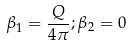<formula> <loc_0><loc_0><loc_500><loc_500>\beta _ { 1 } = \frac { Q } { 4 \pi } ; \beta _ { 2 } = 0</formula> 